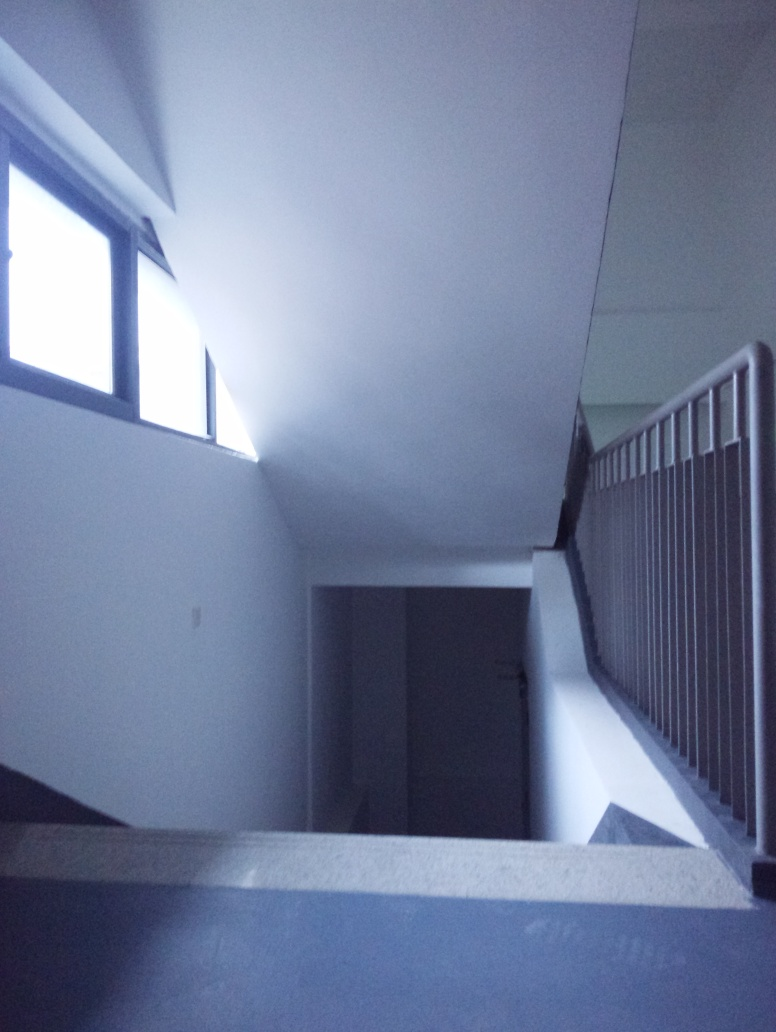How would you describe the contrast of this image? The contrast of the image is generally low, which can be inferred from the muted differences between light and dark areas. While there are some stark differences caused by what appears to be natural light coming from the windows, the shadows and highlights are not very pronounced throughout most of the space. 